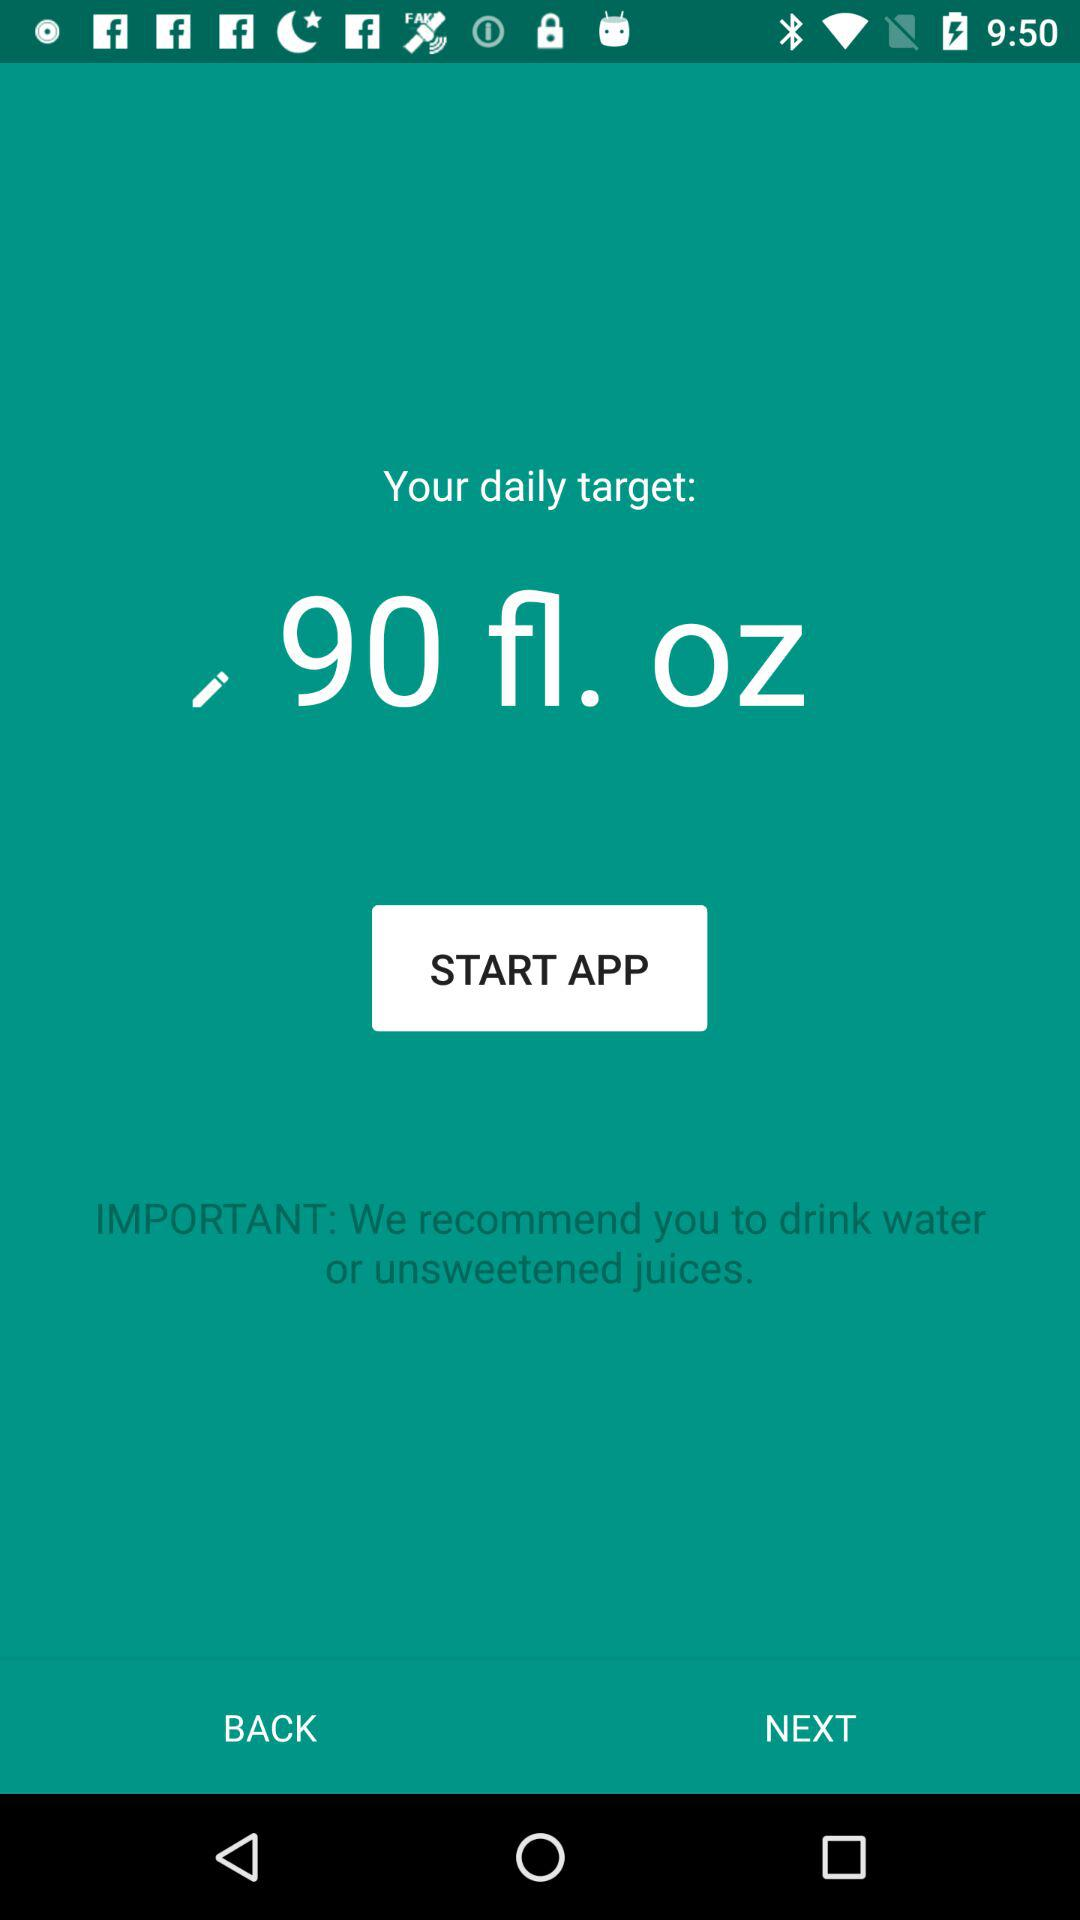What is the daily target? The daily target is 90 fl. oz. 